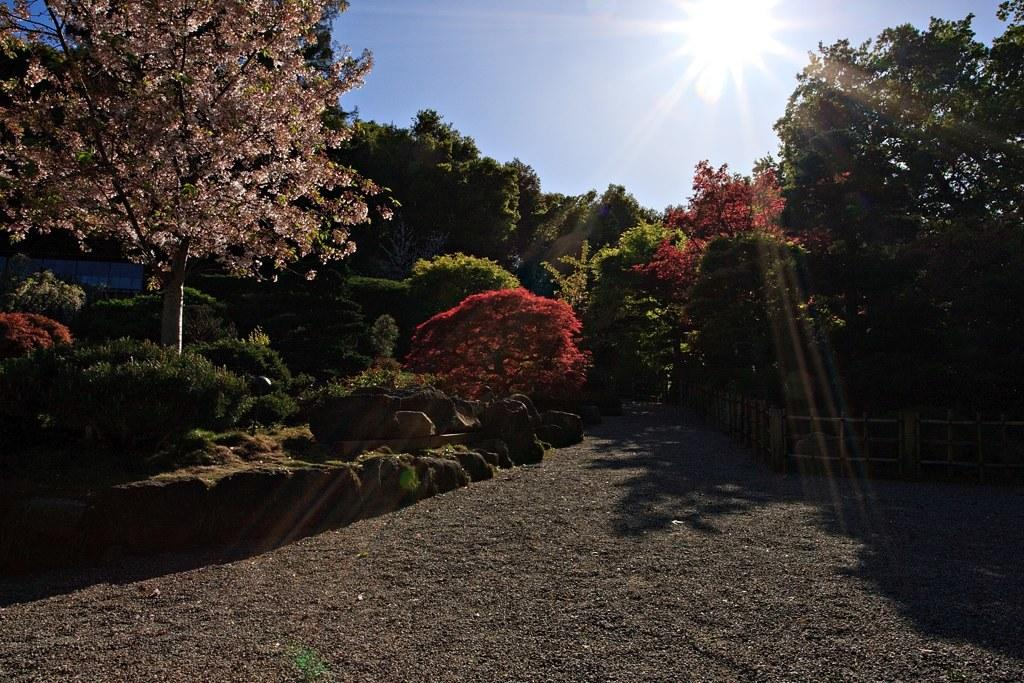What type of vegetation can be seen in the image? There are trees and plants in the image. What is the color of the sky in the image? The sky is blue in the image. Can you describe the lighting in the image? Sunlight is visible in the sky in the image. What type of barrier can be seen in the image? There is a fence in the image. Can you tell me how many firemen are present in the image? There are no firemen present in the image; it features trees, plants, a blue sky, sunlight, and a fence. What type of nose can be seen on the plants in the image? Plants do not have noses, so this detail cannot be observed in the image. 